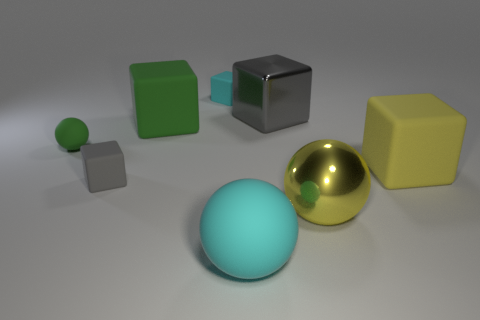Which objects in the image look similar in color and texture, and how are they positioned relative to each other? The two objects sharing a similar cyan color are the large spherical object in the foreground and a smaller cube positioned behind it to the left. Both have a matte texture. The large sphere is prominently placed in the foreground while the smaller cube sits more in the background, creating a sense of depth.  What can you tell me about the lighting in this scene? The scene is illuminated by a soft, diffused light source coming from above, which creates subtle shadows under the objects. This lighting highlights the shapes and surfaces of the objects, emphasizing their textures and giving the scene a calm and balanced ambiance. 